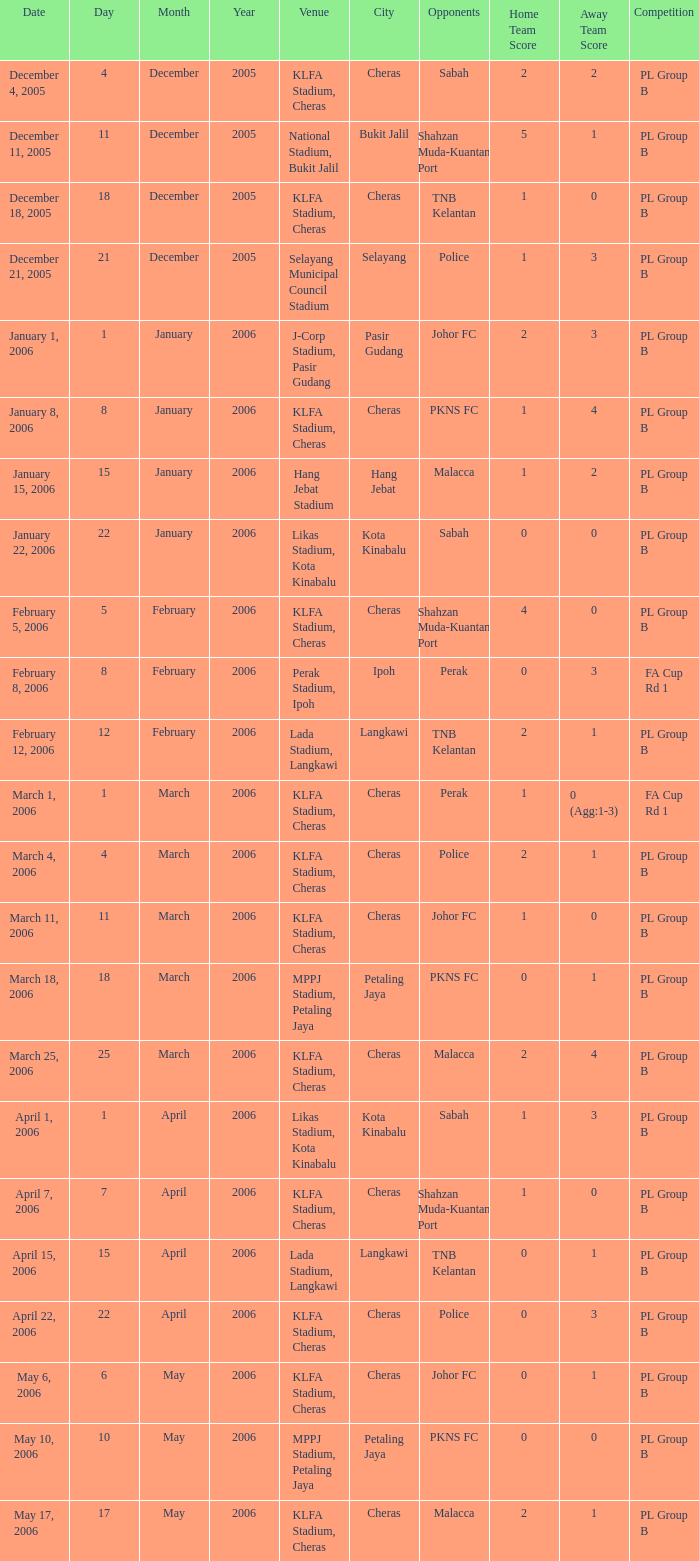Who competed on may 6, 2006? Johor FC. Can you give me this table as a dict? {'header': ['Date', 'Day', 'Month', 'Year', 'Venue', 'City', 'Opponents', 'Home Team Score', 'Away Team Score', 'Competition'], 'rows': [['December 4, 2005', '4', 'December', '2005', 'KLFA Stadium, Cheras', 'Cheras', 'Sabah', '2', '2', 'PL Group B'], ['December 11, 2005', '11', 'December', '2005', 'National Stadium, Bukit Jalil', 'Bukit Jalil', 'Shahzan Muda-Kuantan Port', '5', '1', 'PL Group B'], ['December 18, 2005', '18', 'December', '2005', 'KLFA Stadium, Cheras', 'Cheras', 'TNB Kelantan', '1', '0', 'PL Group B'], ['December 21, 2005', '21', 'December', '2005', 'Selayang Municipal Council Stadium', 'Selayang', 'Police', '1', '3', 'PL Group B'], ['January 1, 2006', '1', 'January', '2006', 'J-Corp Stadium, Pasir Gudang', 'Pasir Gudang', 'Johor FC', '2', '3', 'PL Group B'], ['January 8, 2006', '8', 'January', '2006', 'KLFA Stadium, Cheras', 'Cheras', 'PKNS FC', '1', '4', 'PL Group B'], ['January 15, 2006', '15', 'January', '2006', 'Hang Jebat Stadium', 'Hang Jebat', 'Malacca', '1', '2', 'PL Group B'], ['January 22, 2006', '22', 'January', '2006', 'Likas Stadium, Kota Kinabalu', 'Kota Kinabalu', 'Sabah', '0', '0', 'PL Group B'], ['February 5, 2006', '5', 'February', '2006', 'KLFA Stadium, Cheras', 'Cheras', 'Shahzan Muda-Kuantan Port', '4', '0', 'PL Group B'], ['February 8, 2006', '8', 'February', '2006', 'Perak Stadium, Ipoh', 'Ipoh', 'Perak', '0', '3', 'FA Cup Rd 1'], ['February 12, 2006', '12', 'February', '2006', 'Lada Stadium, Langkawi', 'Langkawi', 'TNB Kelantan', '2', '1', 'PL Group B'], ['March 1, 2006', '1', 'March', '2006', 'KLFA Stadium, Cheras', 'Cheras', 'Perak', '1', '0 (Agg:1-3)', 'FA Cup Rd 1'], ['March 4, 2006', '4', 'March', '2006', 'KLFA Stadium, Cheras', 'Cheras', 'Police', '2', '1', 'PL Group B'], ['March 11, 2006', '11', 'March', '2006', 'KLFA Stadium, Cheras', 'Cheras', 'Johor FC', '1', '0', 'PL Group B'], ['March 18, 2006', '18', 'March', '2006', 'MPPJ Stadium, Petaling Jaya', 'Petaling Jaya', 'PKNS FC', '0', '1', 'PL Group B'], ['March 25, 2006', '25', 'March', '2006', 'KLFA Stadium, Cheras', 'Cheras', 'Malacca', '2', '4', 'PL Group B'], ['April 1, 2006', '1', 'April', '2006', 'Likas Stadium, Kota Kinabalu', 'Kota Kinabalu', 'Sabah', '1', '3', 'PL Group B'], ['April 7, 2006', '7', 'April', '2006', 'KLFA Stadium, Cheras', 'Cheras', 'Shahzan Muda-Kuantan Port', '1', '0', 'PL Group B'], ['April 15, 2006', '15', 'April', '2006', 'Lada Stadium, Langkawi', 'Langkawi', 'TNB Kelantan', '0', '1', 'PL Group B'], ['April 22, 2006', '22', 'April', '2006', 'KLFA Stadium, Cheras', 'Cheras', 'Police', '0', '3', 'PL Group B'], ['May 6, 2006', '6', 'May', '2006', 'KLFA Stadium, Cheras', 'Cheras', 'Johor FC', '0', '1', 'PL Group B'], ['May 10, 2006', '10', 'May', '2006', 'MPPJ Stadium, Petaling Jaya', 'Petaling Jaya', 'PKNS FC', '0', '0', 'PL Group B'], ['May 17, 2006', '17', 'May', '2006', 'KLFA Stadium, Cheras', 'Cheras', 'Malacca', '2', '1', 'PL Group B']]} 